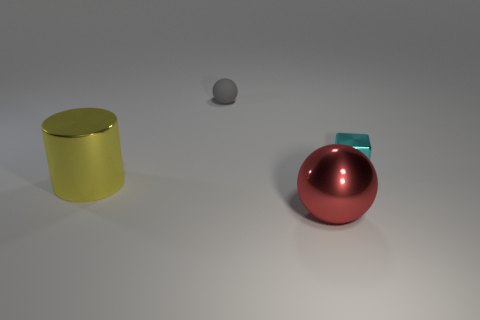The large thing in front of the big cylinder has what shape?
Your answer should be very brief. Sphere. Are there fewer green shiny cylinders than rubber balls?
Offer a terse response. Yes. Is there any other thing of the same color as the big ball?
Offer a terse response. No. There is a ball that is in front of the large yellow metal thing; what is its size?
Make the answer very short. Large. Is the number of small blue metallic objects greater than the number of small gray matte spheres?
Your answer should be compact. No. What material is the big cylinder?
Your answer should be compact. Metal. What number of other objects are there of the same material as the big red thing?
Provide a succinct answer. 2. What number of tiny gray rubber objects are there?
Ensure brevity in your answer.  1. There is another thing that is the same shape as the red metal thing; what is it made of?
Offer a very short reply. Rubber. Is the material of the object that is on the left side of the tiny rubber object the same as the block?
Your response must be concise. Yes. 